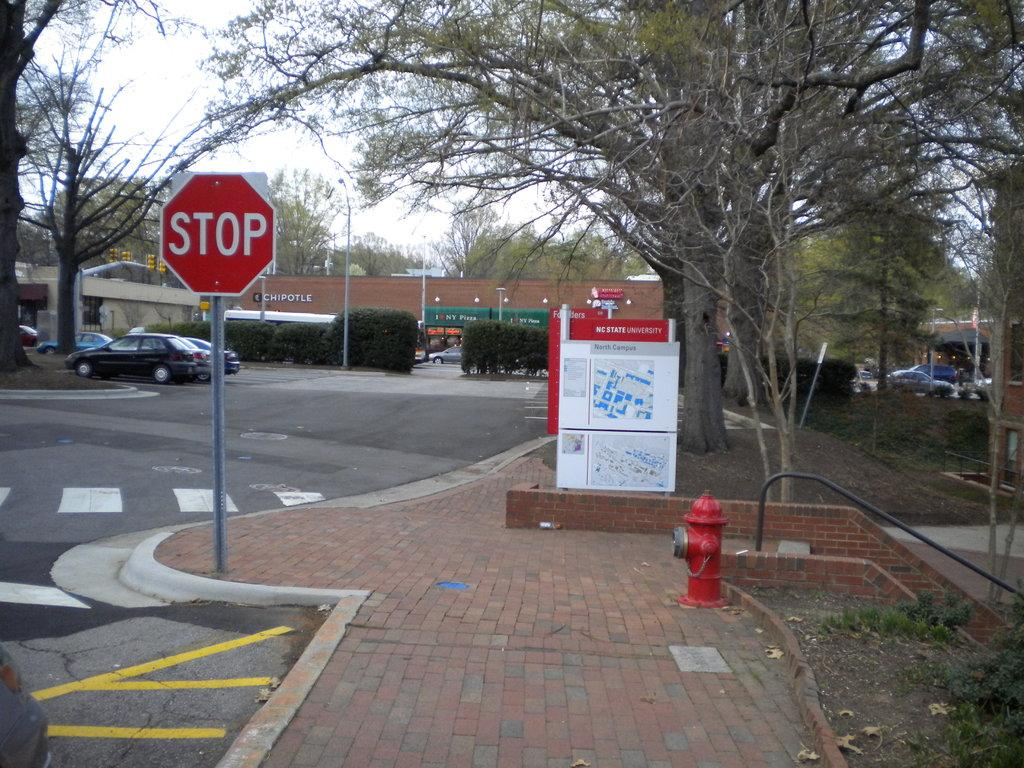<image>
Write a terse but informative summary of the picture. A stop sign and map for NC State University with a Chipotle in the background. 